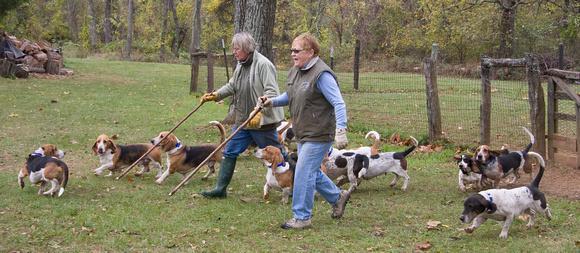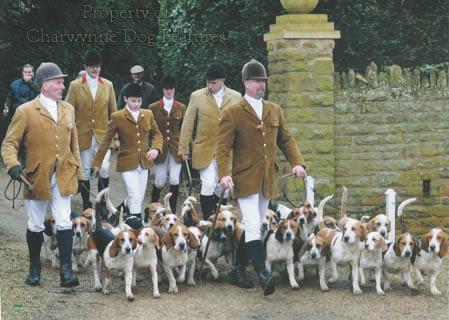The first image is the image on the left, the second image is the image on the right. For the images shown, is this caption "Dogs are playing in at least one of the images." true? Answer yes or no. No. The first image is the image on the left, the second image is the image on the right. For the images displayed, is the sentence "All dogs are moving away from the camera in one image." factually correct? Answer yes or no. No. 